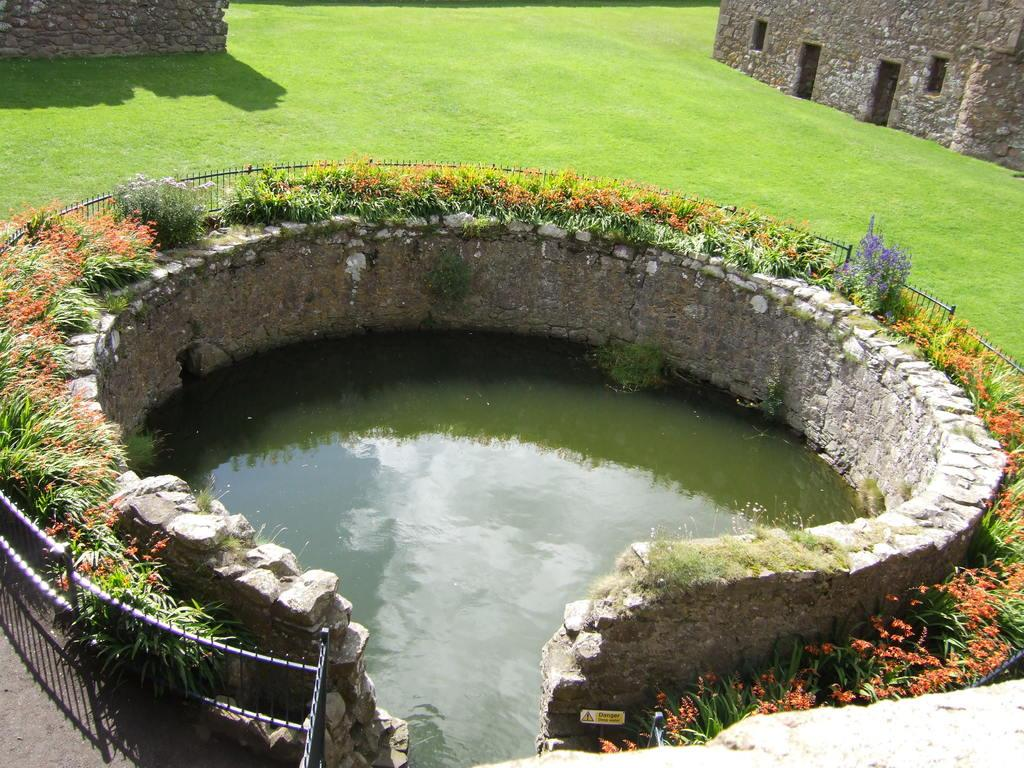What is the main structure in the center of the image? There is a well in the center of the image. What feature surrounds the well? There is railing around the well. What type of vegetation can be seen in the image? Some plants are present in the image, and there is grass visible as well. What can be seen in the background of the image? There are buildings in the background of the image. What is the surface at the bottom of the image? There is a walkway at the bottom of the image. Can you hear a whistle coming from the well in the image? There is no indication of a whistle or any sound in the image, as it is a still photograph. Is the sister of the person taking the photo visible in the image? There is no information about the person taking the photo or their relatives, so it cannot be determined if the sister is present in the image. 